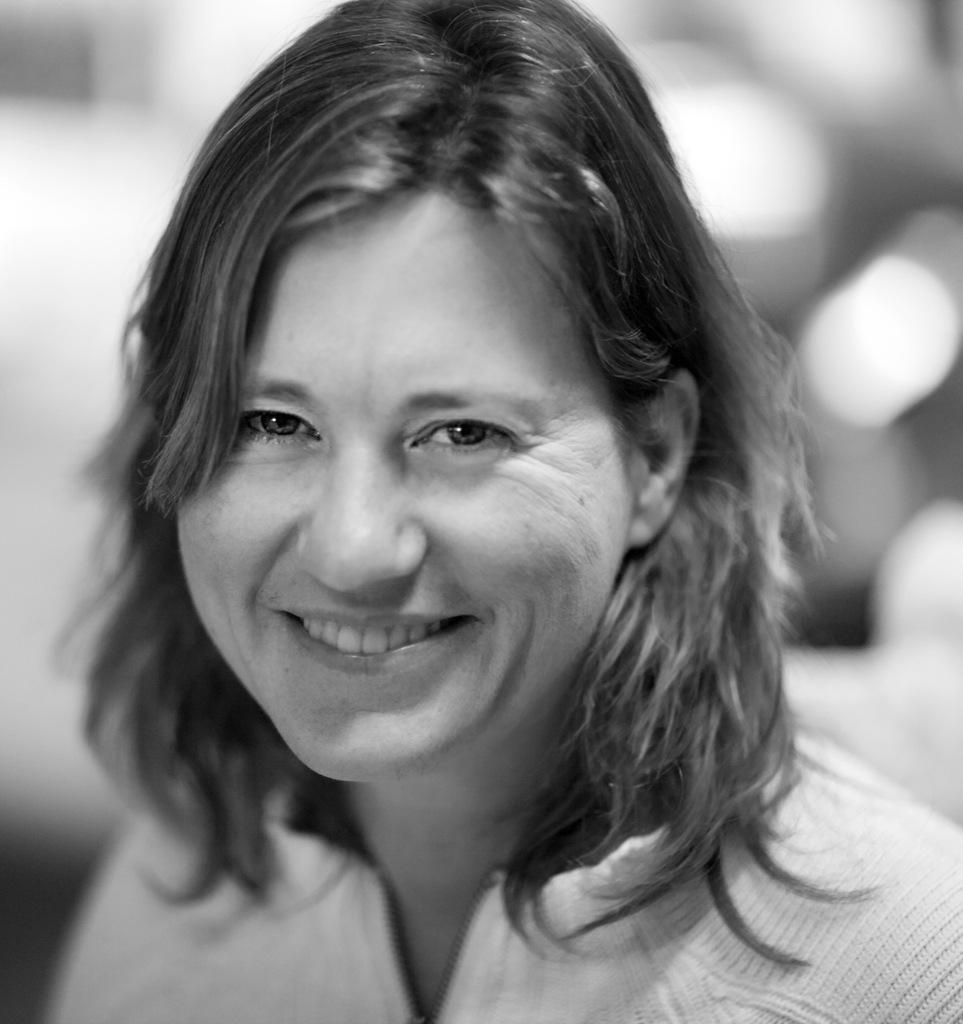What can be observed about the composition of the image? The image is truncated towards the bottom. What can be said about the background of the image? The background of the image is blurred. What type of teaching method is being demonstrated in the image? There is no teaching method or any indication of teaching in the image. Can you identify any war-related elements in the image? There are no war-related elements present in the image. 